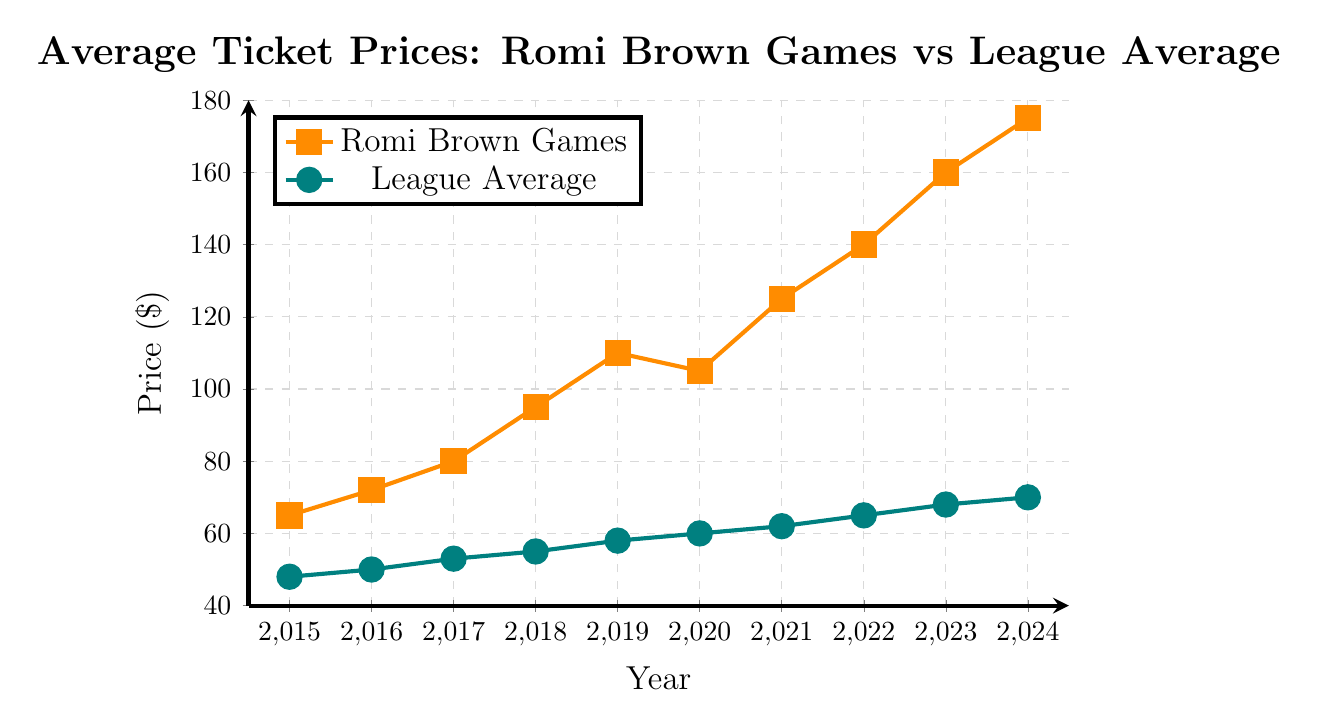How do the ticket prices for Romi Brown games in 2020 compare to the league average in the same year? In 2020, the ticket price for Romi Brown games is $105, whereas the league average is $60. The price for Romi Brown games is higher.
Answer: Higher What is the difference in ticket prices between Romi Brown games and the league average in 2024? In 2024, the ticket price for Romi Brown games is $175 and the league average is $70. The difference is $175 - $70 = $105.
Answer: $105 What is the average ticket price for Romi Brown games from 2015 to 2024? Sum all the ticket prices for Romi Brown games from 2015 to 2024: 65 + 72 + 80 + 95 + 110 + 105 + 125 + 140 + 160 + 175 = 1127. Divide by the number of years (10): 1127 / 10 = 112.7.
Answer: 112.7 In which year did Romi Brown games have the highest ticket price increments compared to the previous year? The increments in Romi Brown ticket prices are: 2016: 72-65 = 7, 2017: 80-72 = 8, 2018: 95-80 = 15, 2019: 110-95 = 15, 2020: 105-110 = -5, 2021: 125-105 = 20, 2022: 140-125 = 15, 2023: 160-140 = 20, 2024: 175-160 = 15. The highest increase is in 2021 and 2023 with an increment of 20.
Answer: 2021 and 2023 Compare the trend of ticket prices for Romi Brown games and the league average from 2015 to 2024. Both Romi Brown games and league average ticket prices show an increasing trend over the years. However, Romi Brown games increase at a faster rate, leading to a larger gap over time.
Answer: Romi Brown games increase faster Between which years did the ticket prices for Romi Brown games increase the least? The smallest increment for Romi Brown games is between 2019 and 2020, where the price decreased from $110 to $105.
Answer: 2019-2020 What are the colors used to denote Romi Brown games and the league average respectively? The Romi Brown games are denoted in orange, while the league average is in teal.
Answer: Orange, Teal What is the visual difference in markers used for Romi Brown games and the league average? Romi Brown games use square markers, while the league average uses circular markers.
Answer: Square, Circular Are there any years where the ticket prices for Romi Brown games decrease compared to the previous year? Yes, in 2020, the ticket price for Romi Brown games decreased compared to 2019.
Answer: Yes What is the average ticket price for the league across 2015-2024? Sum all the league average ticket prices from 2015 to 2024: 48 + 50 + 53 + 55 + 58 + 60 + 62 + 65 + 68 + 70 = 589. Divide by the number of years (10): 589 / 10 = 58.9.
Answer: 58.9 